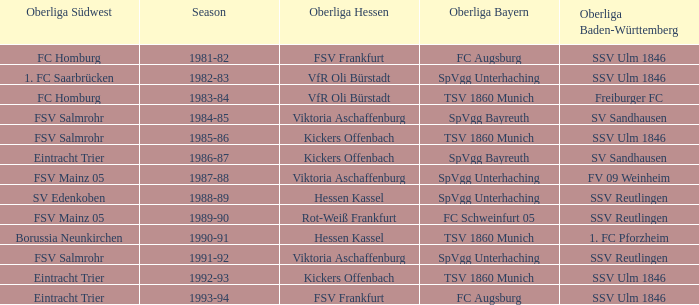Which Season ha spvgg bayreuth and eintracht trier? 1986-87. 